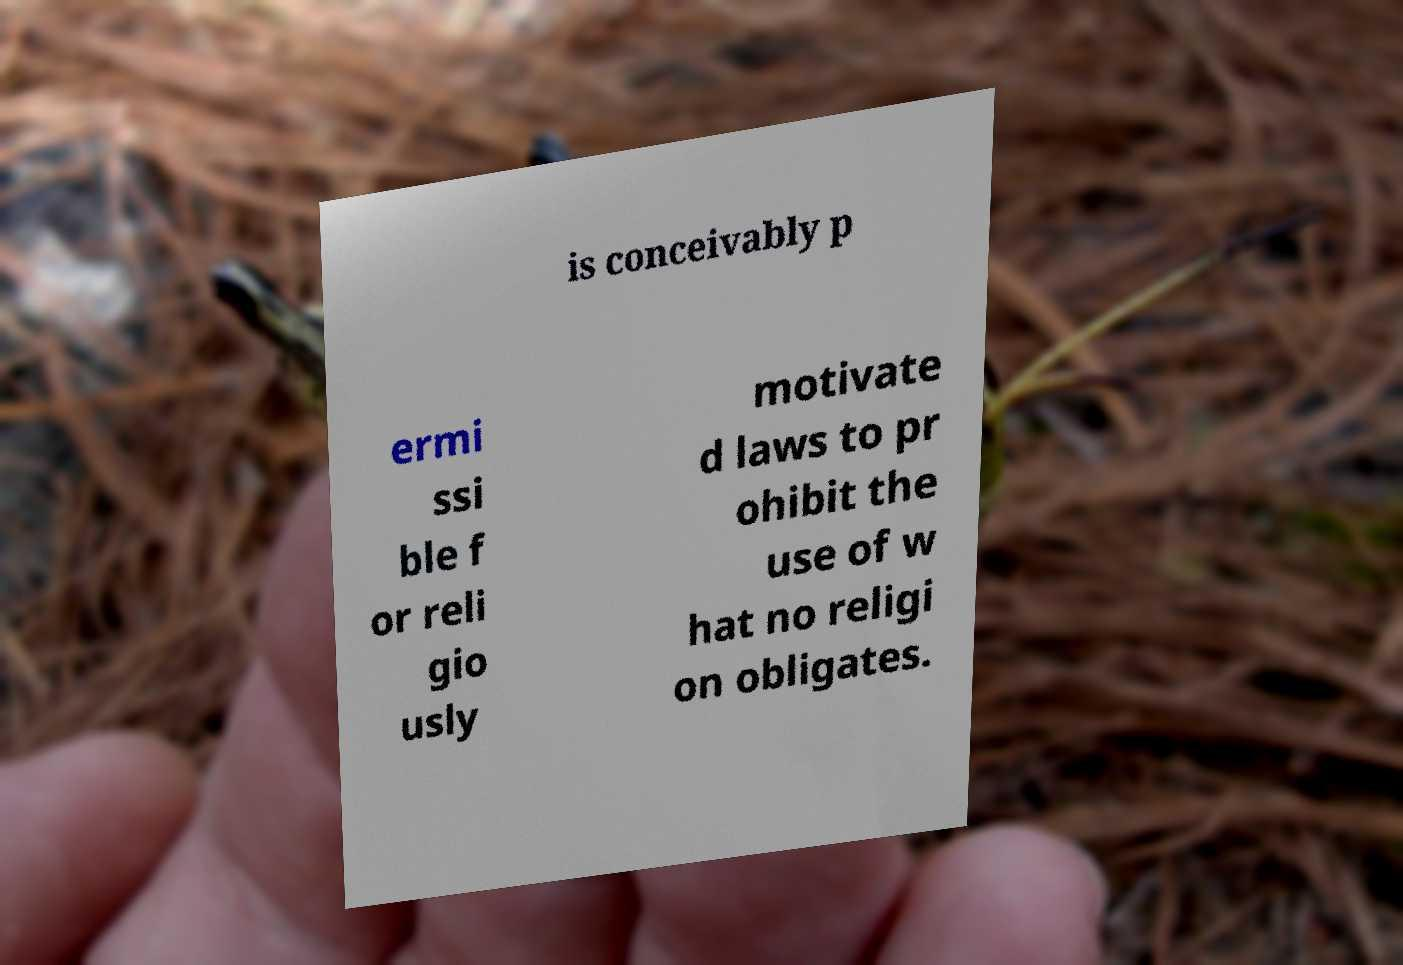Please identify and transcribe the text found in this image. is conceivably p ermi ssi ble f or reli gio usly motivate d laws to pr ohibit the use of w hat no religi on obligates. 